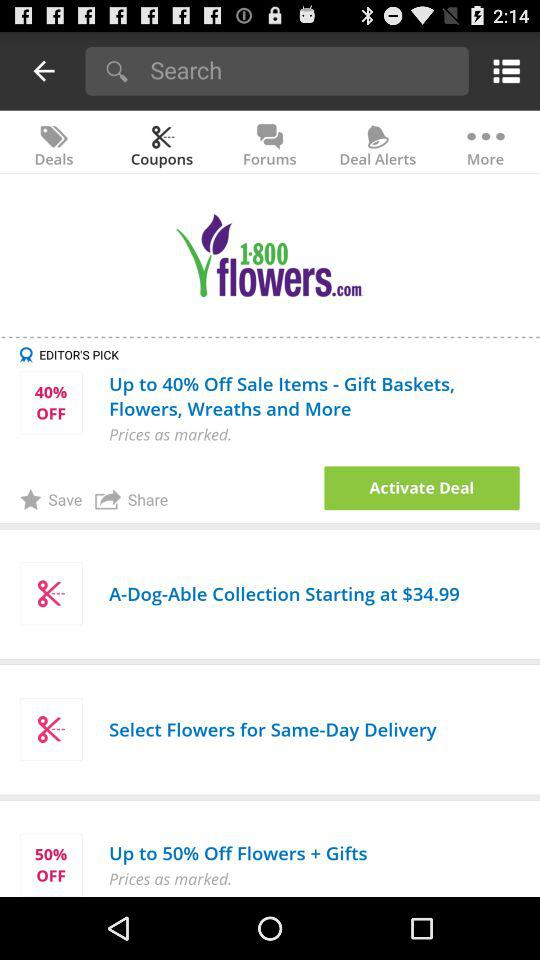How much is the discount on the "Sale Items"? The discount is up to 40% on the "Sale Items". 